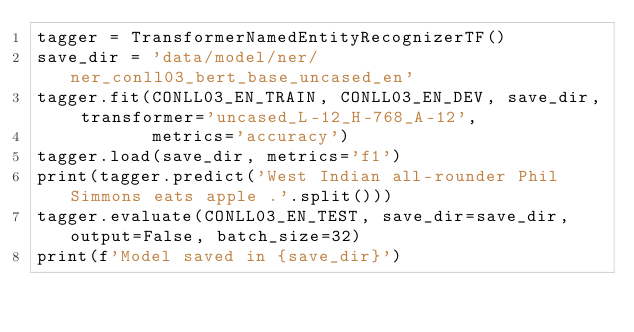Convert code to text. <code><loc_0><loc_0><loc_500><loc_500><_Python_>tagger = TransformerNamedEntityRecognizerTF()
save_dir = 'data/model/ner/ner_conll03_bert_base_uncased_en'
tagger.fit(CONLL03_EN_TRAIN, CONLL03_EN_DEV, save_dir, transformer='uncased_L-12_H-768_A-12',
           metrics='accuracy')
tagger.load(save_dir, metrics='f1')
print(tagger.predict('West Indian all-rounder Phil Simmons eats apple .'.split()))
tagger.evaluate(CONLL03_EN_TEST, save_dir=save_dir, output=False, batch_size=32)
print(f'Model saved in {save_dir}')</code> 